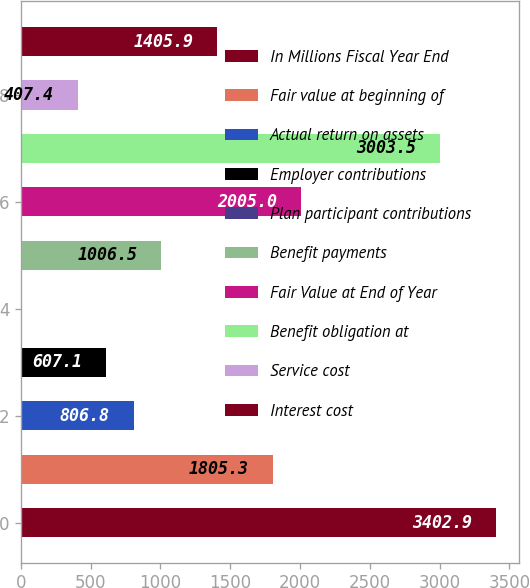Convert chart. <chart><loc_0><loc_0><loc_500><loc_500><bar_chart><fcel>In Millions Fiscal Year End<fcel>Fair value at beginning of<fcel>Actual return on assets<fcel>Employer contributions<fcel>Plan participant contributions<fcel>Benefit payments<fcel>Fair Value at End of Year<fcel>Benefit obligation at<fcel>Service cost<fcel>Interest cost<nl><fcel>3402.9<fcel>1805.3<fcel>806.8<fcel>607.1<fcel>8<fcel>1006.5<fcel>2005<fcel>3003.5<fcel>407.4<fcel>1405.9<nl></chart> 